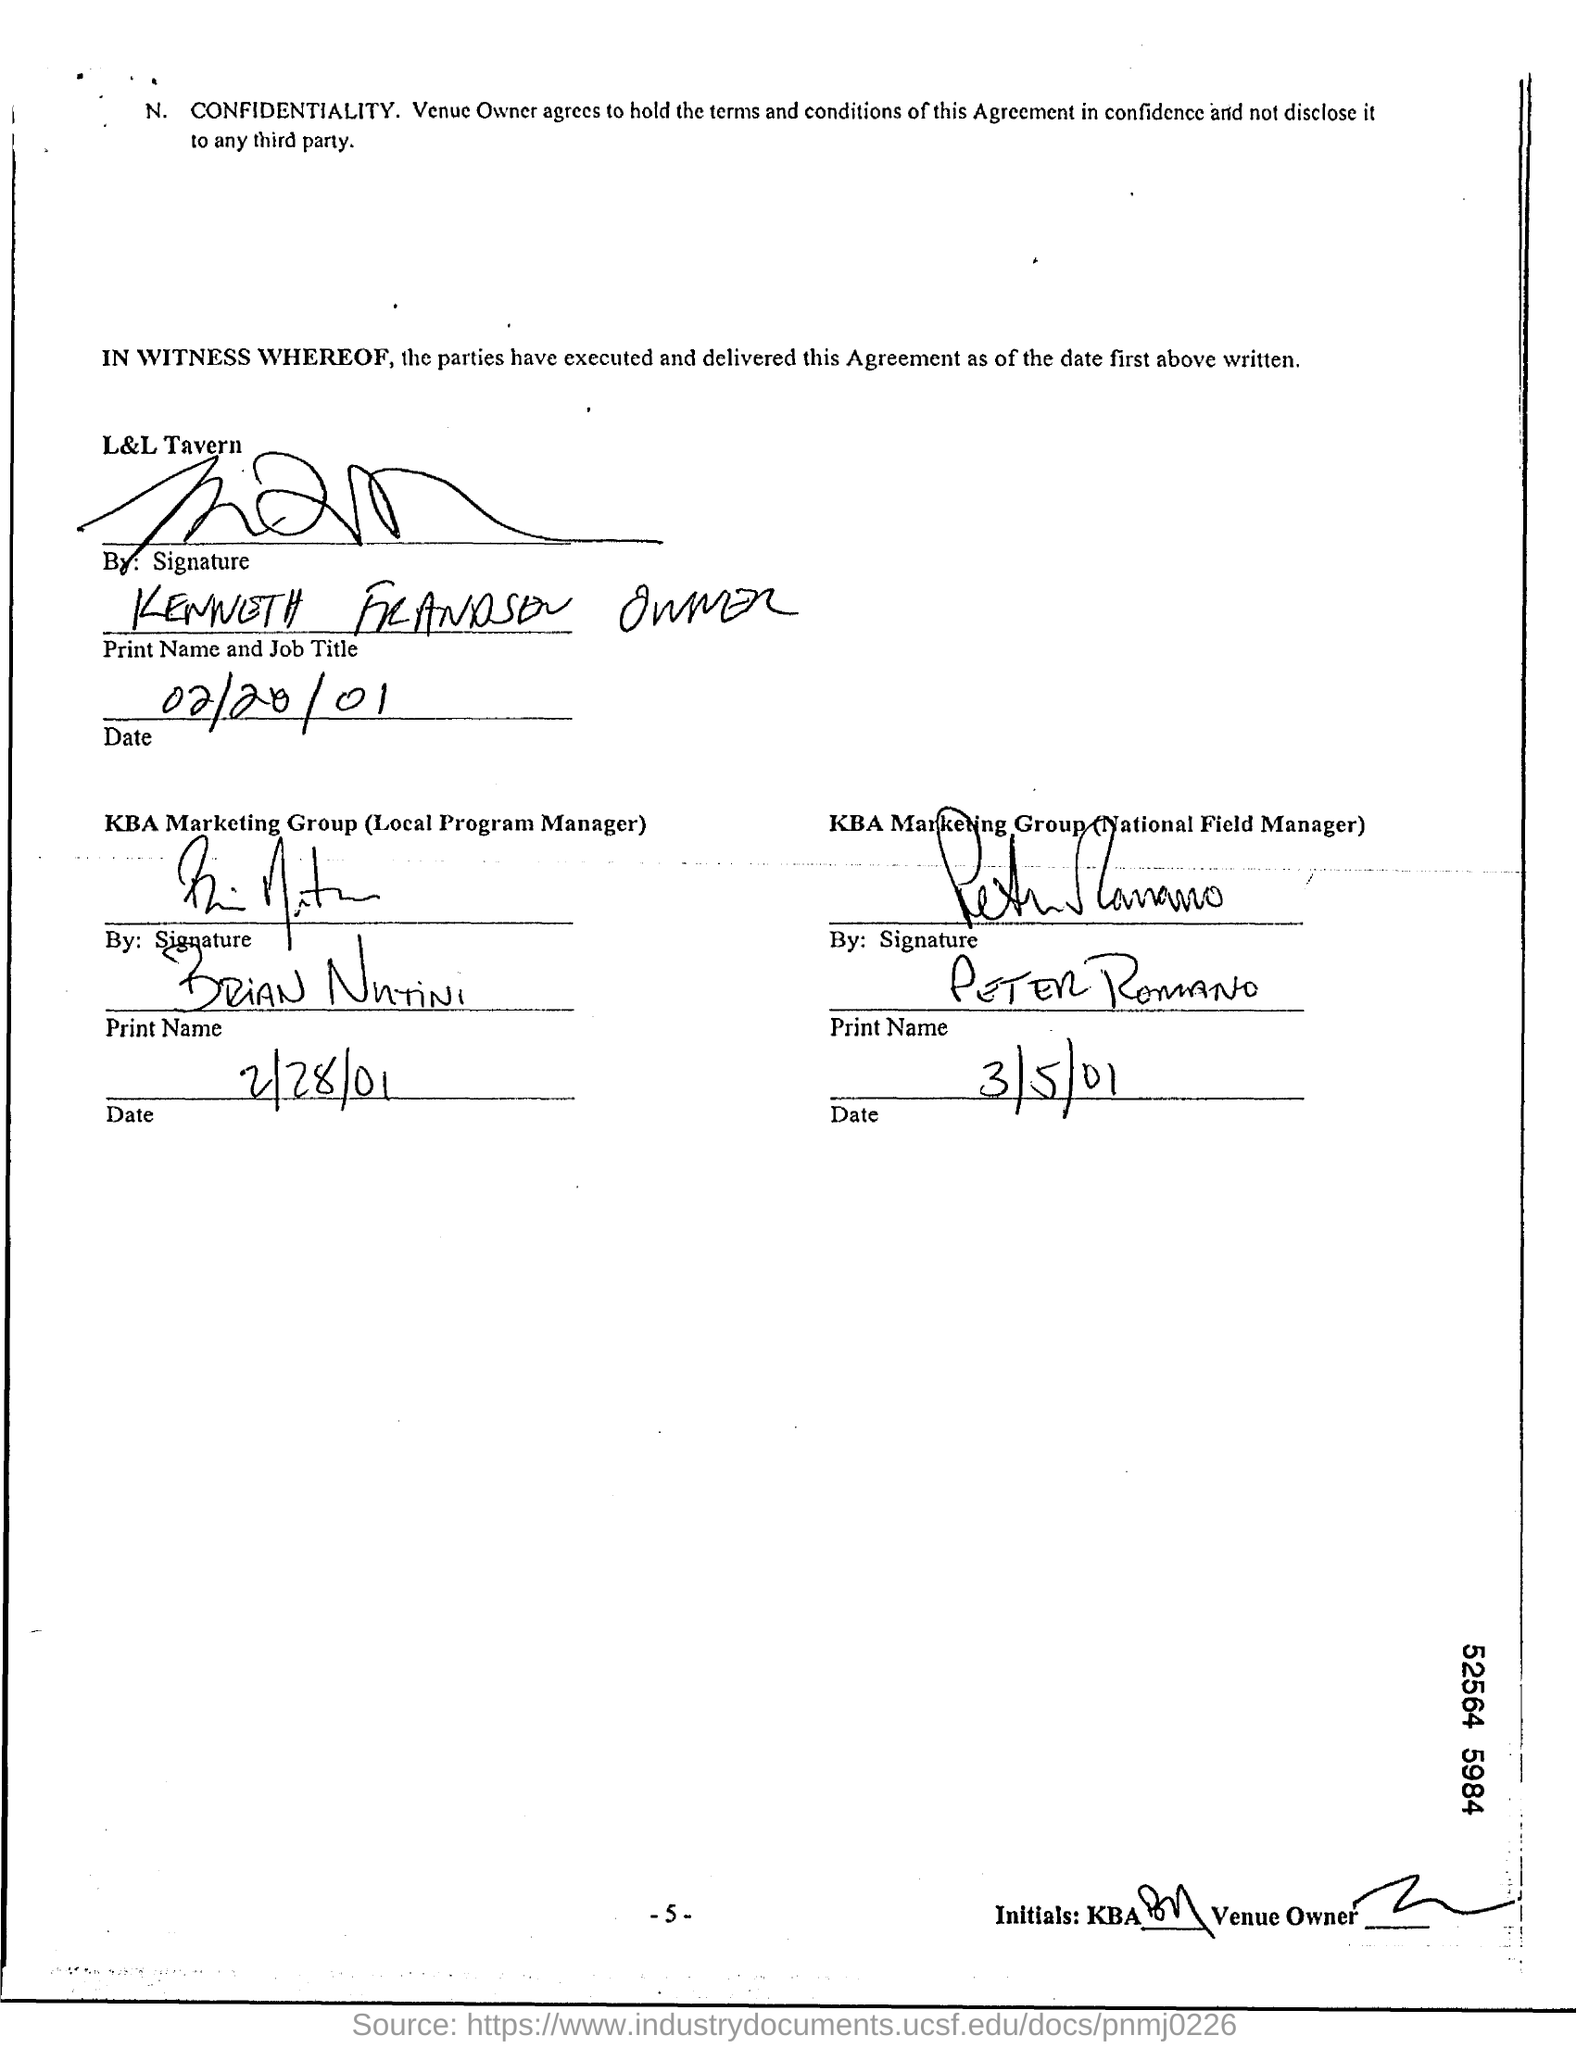Outline some significant characteristics in this image. The name of the National Field Manager of the KBA Marketing Group is Peter Romano. The date mentioned under KBA Marketing Group (Local Program Manager) is February 28th, 2001. The date written under KBA Marketing Group (National Field Manager) is March 5, 2001. The date written on L&L Tavern is February 20, 2001. Brian Nutini is the Local Program Manager of KBA Marketing Group. 